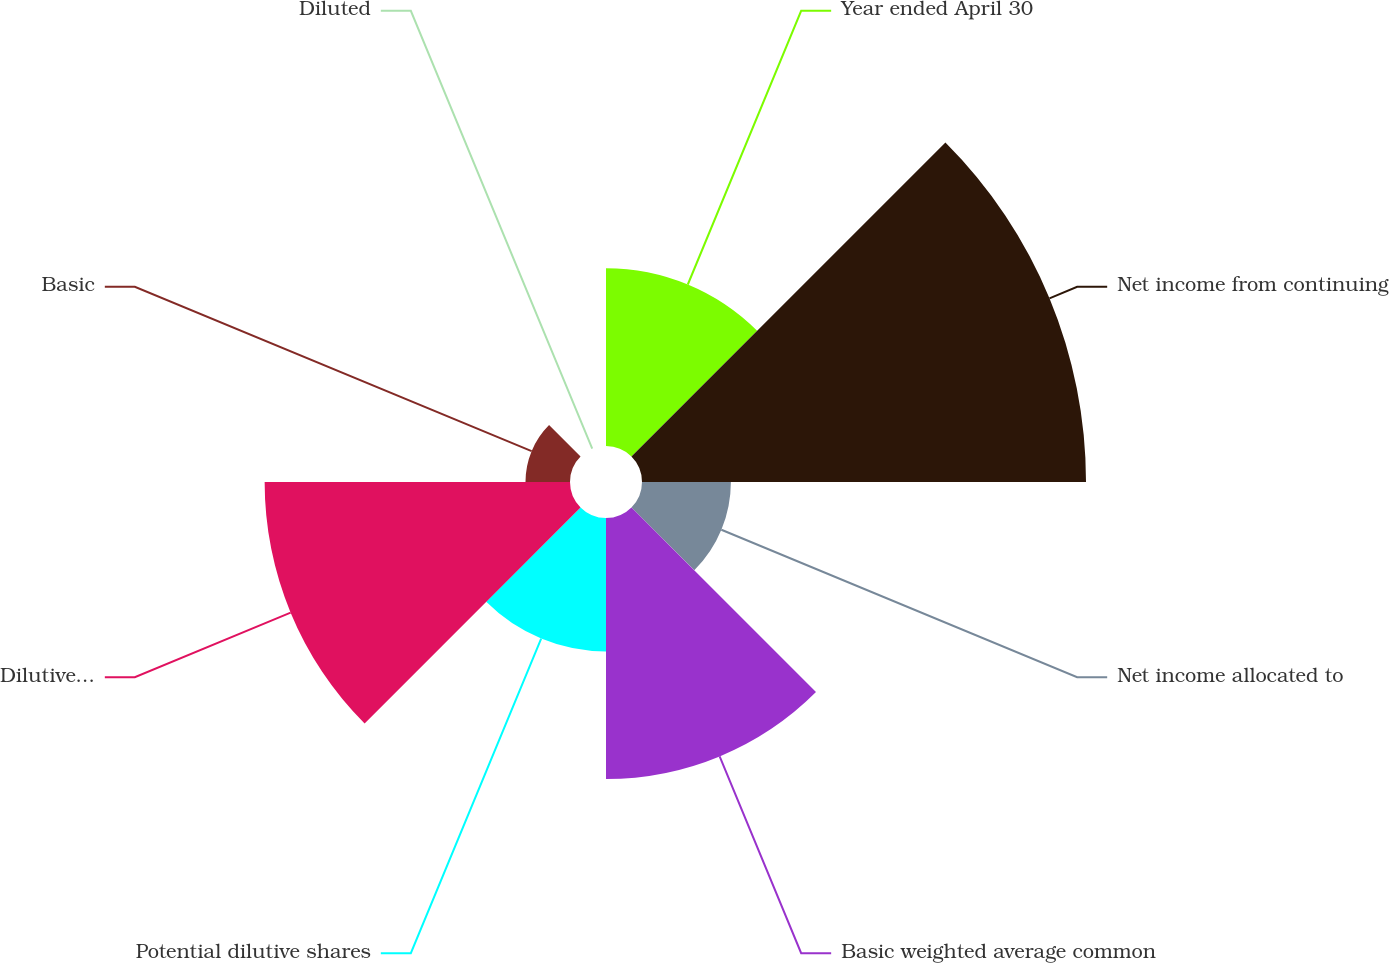<chart> <loc_0><loc_0><loc_500><loc_500><pie_chart><fcel>Year ended April 30<fcel>Net income from continuing<fcel>Net income allocated to<fcel>Basic weighted average common<fcel>Potential dilutive shares<fcel>Dilutive weighted average<fcel>Basic<fcel>Diluted<nl><fcel>12.22%<fcel>30.52%<fcel>6.11%<fcel>17.94%<fcel>9.17%<fcel>20.99%<fcel>3.06%<fcel>0.0%<nl></chart> 